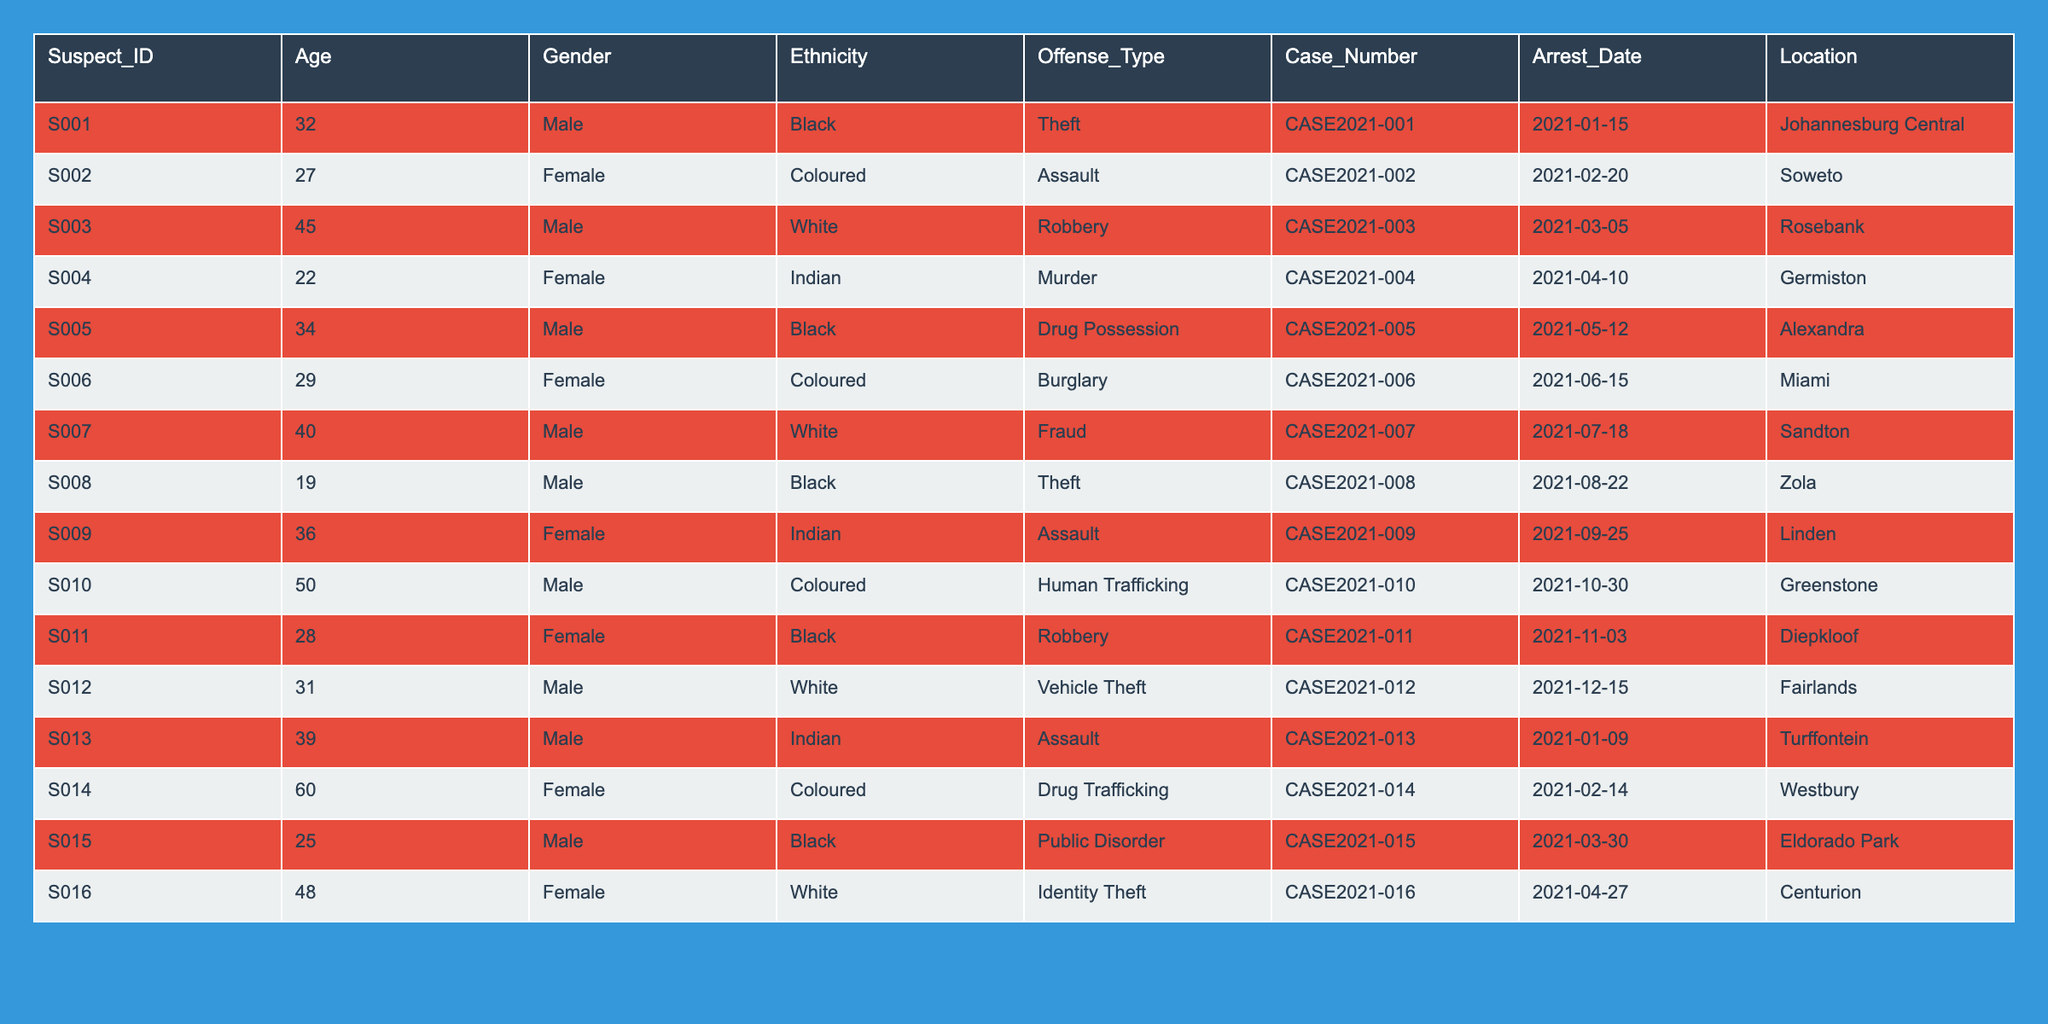What is the most common offense type among the suspects? To find the most common offense type, we list all offense types: Theft, Assault, Robbery, Murder, Drug Possession, Burglary, Fraud, Human Trafficking, Public Disorder, Drug Trafficking, and Identity Theft. Counting each one, Theft appears twice, Assault appears three times, and the others once. Assault is the most common offense type in this dataset.
Answer: Assault How many female suspects are there? By scanning through the Gender column, we count the entries labeled "Female." There are five female suspects: S002, S004, S006, S009, and S016. Thus, the total count of female suspects is five.
Answer: 5 What is the average age of the suspects? To find the average age, we first sum the ages of all suspects: (32 + 27 + 45 + 22 + 34 + 29 + 40 + 19 + 36 + 50 + 28 + 31 + 39 + 60 + 25 + 48) = 711. There are 16 suspects, so the average age is 711/16 = 44.44.
Answer: 44.44 Is there any suspect involved in theft who is under 30 years old? We review the table for suspects charged with Theft and check their ages. Only S008, who is 19 years old, is involved in theft and is under 30 years old. Hence, the answer is yes.
Answer: Yes What percentage of suspects are male? To find the percentage of male suspects, we first count the total number of male suspects, which are 11 (from S001, S003, S005, S007, S008, S010, S011, S012, S013, S015, and S016) out of a total of 16 suspects. The percentage is calculated as (11/16) * 100 = 68.75%.
Answer: 68.75% Which location has the highest number of suspects? We check the Location column for occurrences. The locations listed are: Johannesburg Central, Soweto, Rosebank, Germiston, Alexandra, Miami, Sandton, Zola, Linden, Greenstone, Diepkloof, Turffontein, Westbury, Eldorado Park, and Centurion. Each appears once, except for Johannesburg Central and Soweto, which both have one suspect each, and we find no location with more than one suspect. Thus, multiple locations are tied for the highest count, each with one suspect.
Answer: Multiple locations with one suspect each Are there more suspects charged with drug-related offenses than violence-related offenses? The drug-related charges are Drug Possession (S005), Drug Trafficking (S014), and Human Trafficking (S010). The violence-related charges are Assault (S002, S009, S011, S013) and Murder (S004). Counting, we find three suspects for drug-related offenses and four for violence-related offenses. Therefore, there are fewer drug-related suspects.
Answer: No What is the total number of distinct offense types? By looking at the Offense_Type column, we identify: Theft, Assault, Robbery, Murder, Drug Possession, Burglary, Fraud, Human Trafficking, Public Disorder, Drug Trafficking, and Identity Theft. This sums to a total of 11 distinct offense types.
Answer: 11 